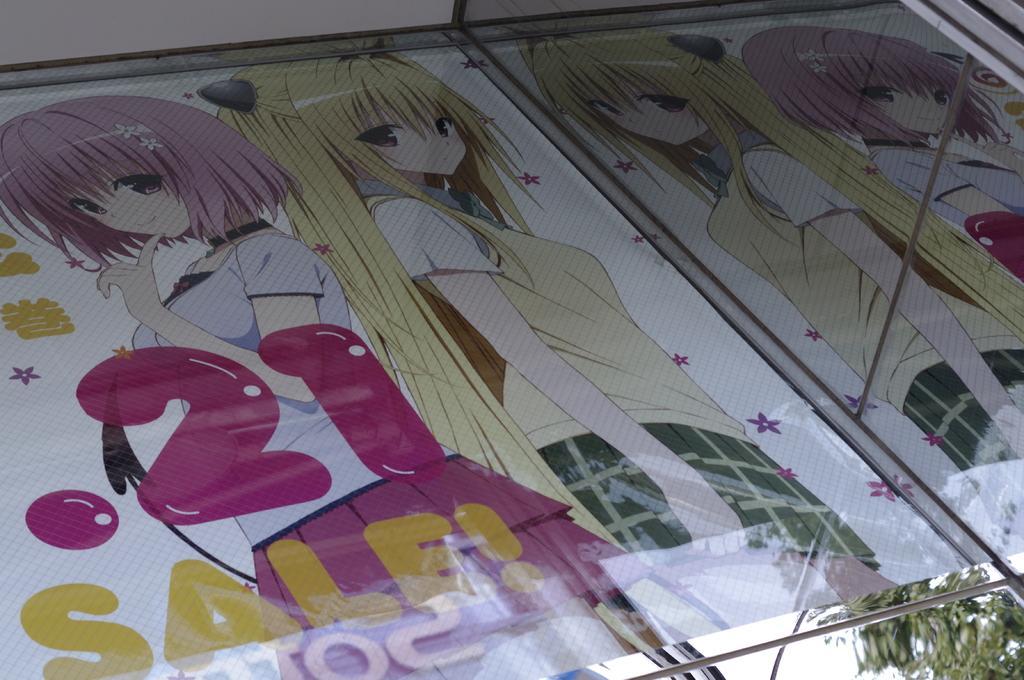Please provide a concise description of this image. In this image we can see a banner of two girls. 